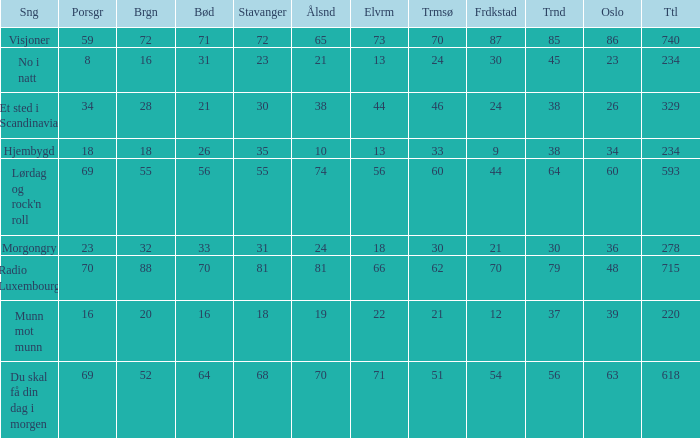When the total score is 740, what is tromso? 70.0. 